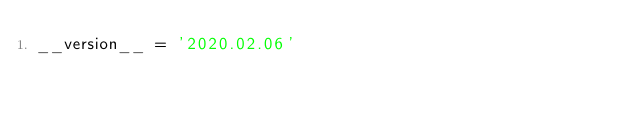Convert code to text. <code><loc_0><loc_0><loc_500><loc_500><_Python_>__version__ = '2020.02.06'
</code> 